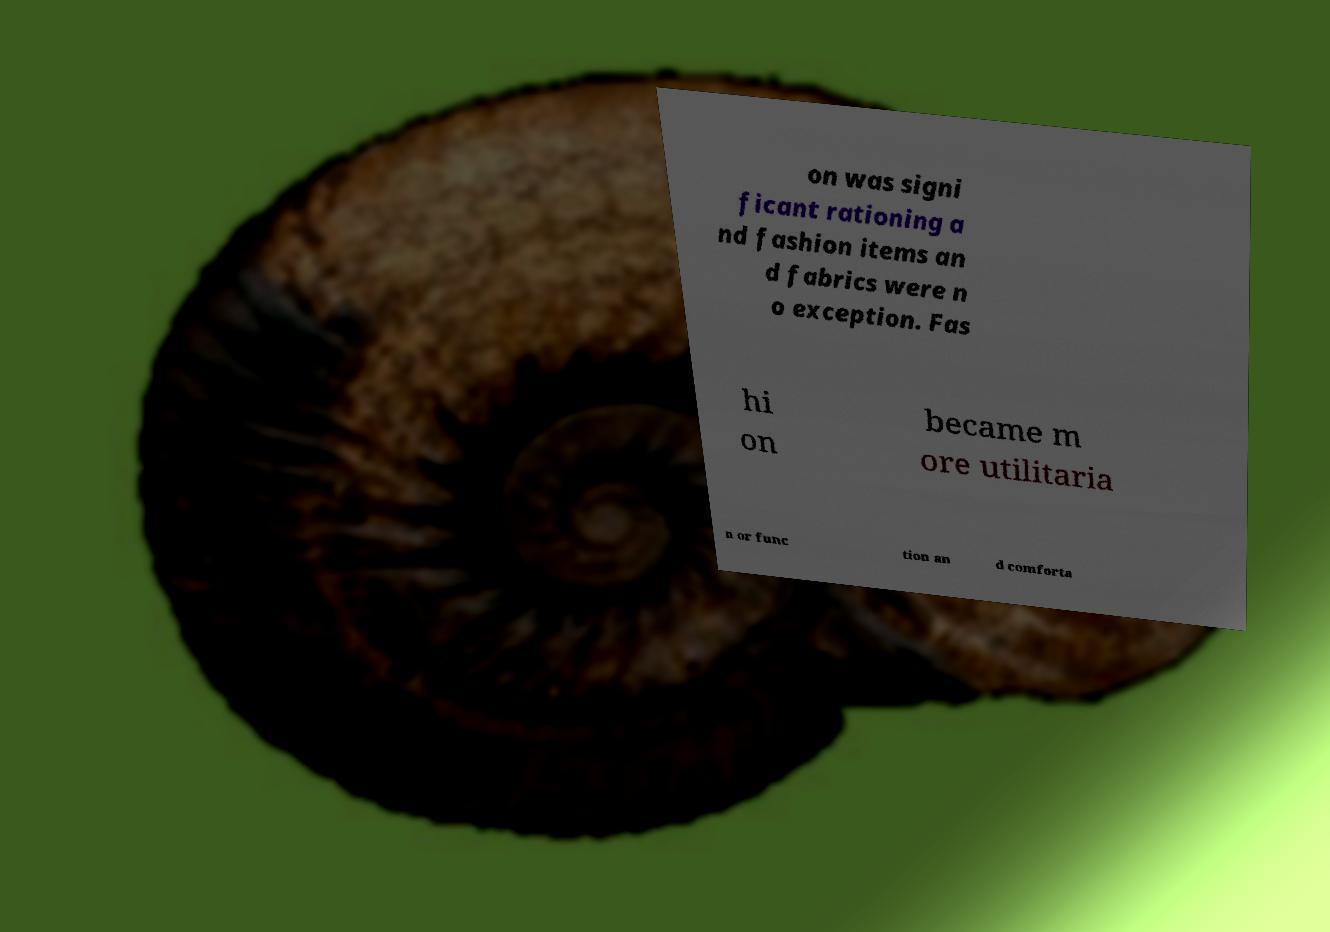Can you accurately transcribe the text from the provided image for me? on was signi ficant rationing a nd fashion items an d fabrics were n o exception. Fas hi on became m ore utilitaria n or func tion an d comforta 